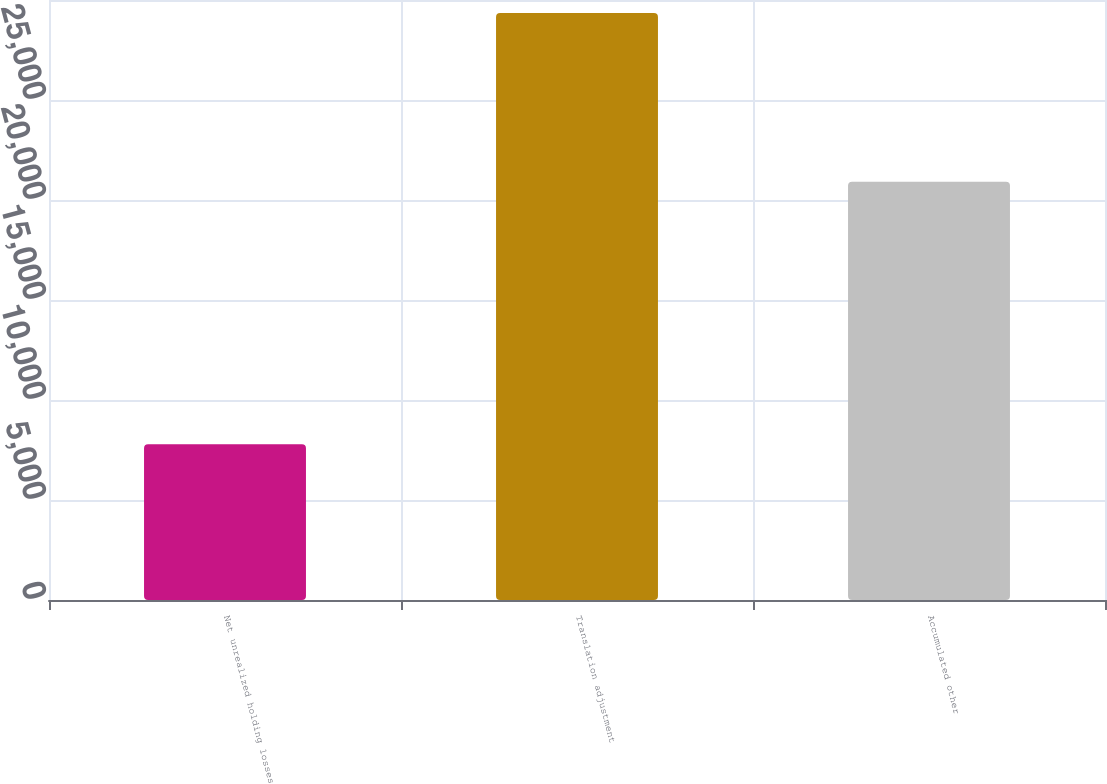Convert chart to OTSL. <chart><loc_0><loc_0><loc_500><loc_500><bar_chart><fcel>Net unrealized holding losses<fcel>Translation adjustment<fcel>Accumulated other<nl><fcel>7786<fcel>29351<fcel>20914<nl></chart> 